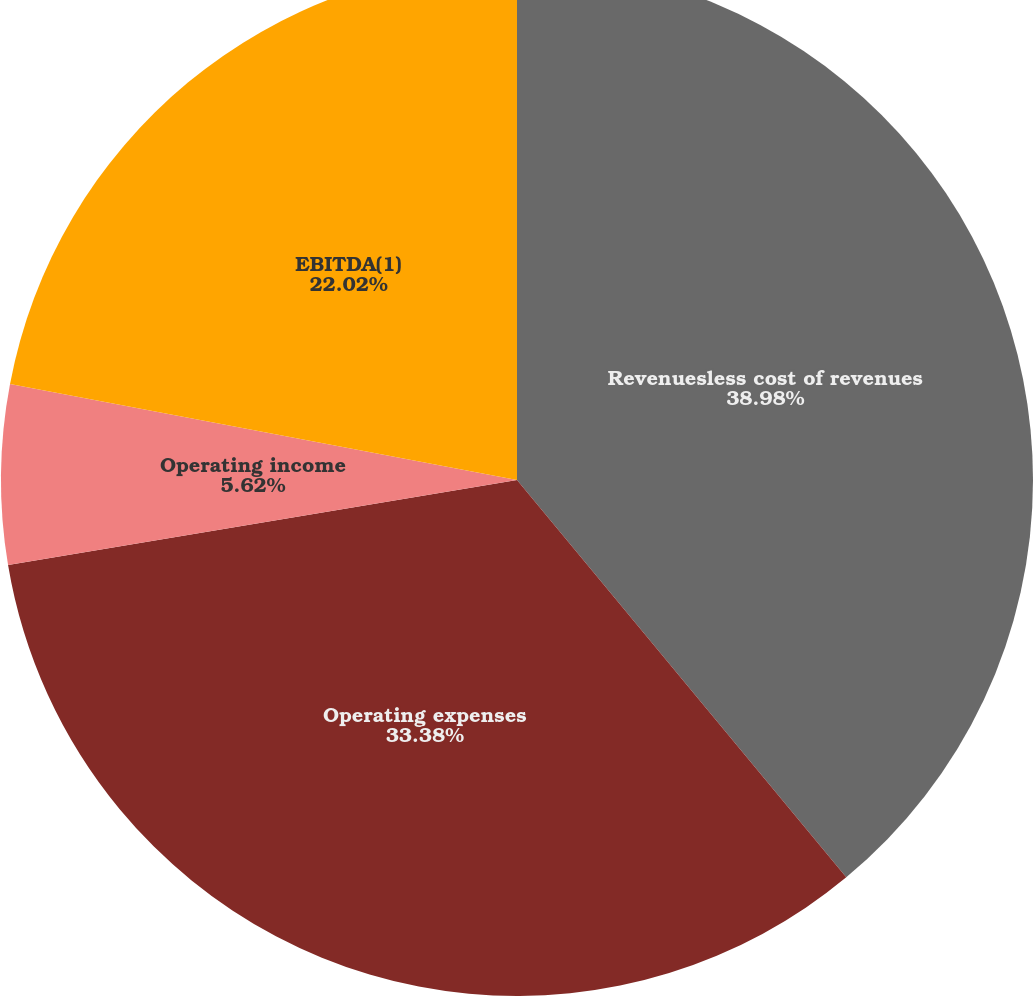Convert chart to OTSL. <chart><loc_0><loc_0><loc_500><loc_500><pie_chart><fcel>Revenuesless cost of revenues<fcel>Operating expenses<fcel>Operating income<fcel>EBITDA(1)<nl><fcel>38.99%<fcel>33.38%<fcel>5.62%<fcel>22.02%<nl></chart> 